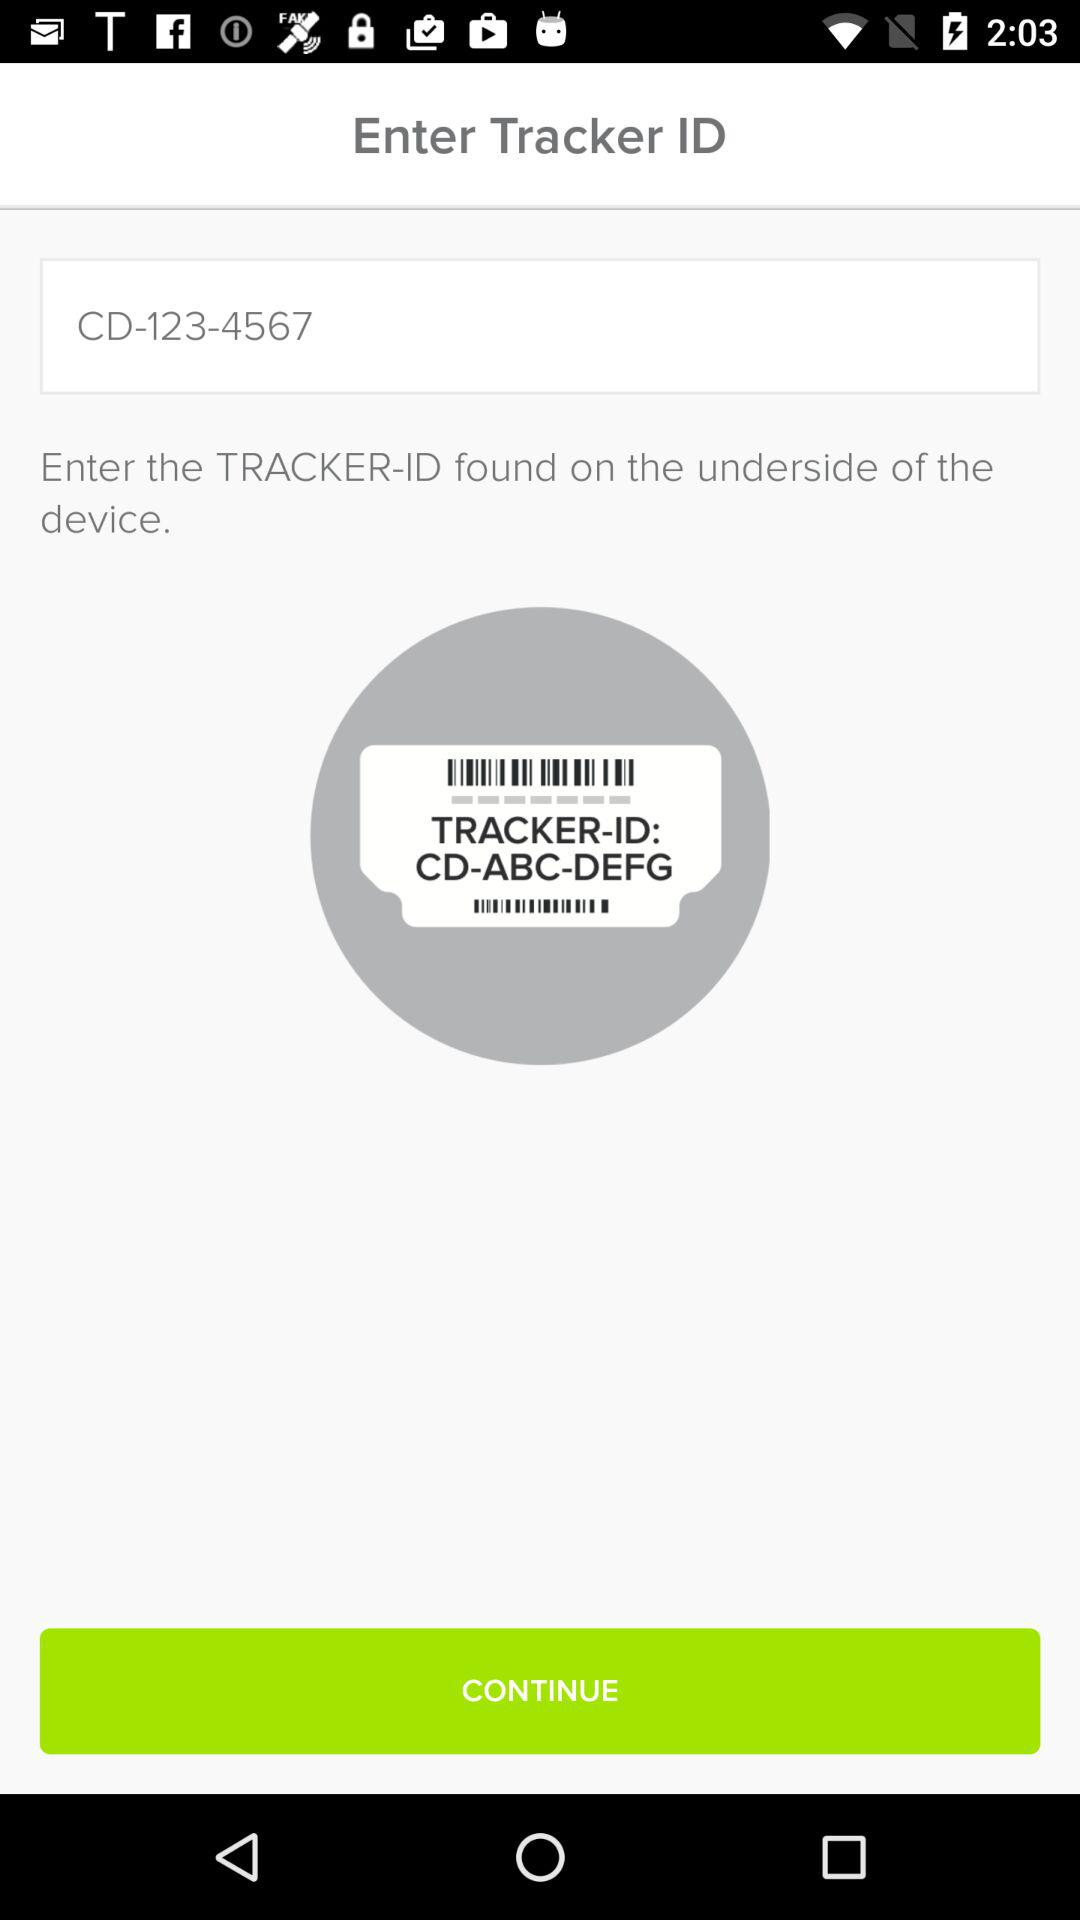What type of device is it?
When the provided information is insufficient, respond with <no answer>. <no answer> 